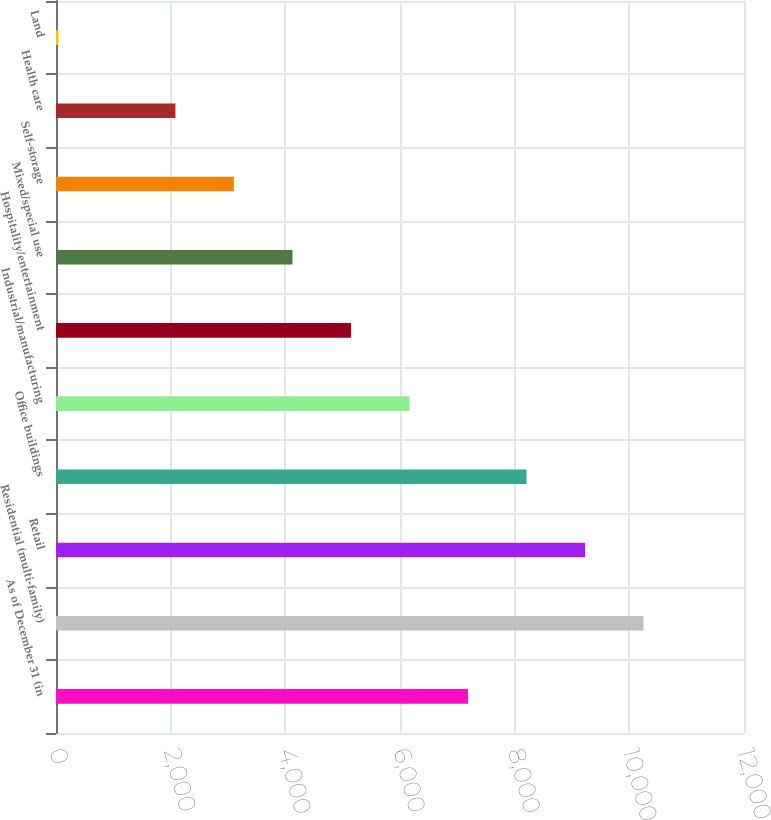<chart> <loc_0><loc_0><loc_500><loc_500><bar_chart><fcel>As of December 31 (in<fcel>Residential (multi-family)<fcel>Retail<fcel>Office buildings<fcel>Industrial/manufacturing<fcel>Hospitality/entertainment<fcel>Mixed/special use<fcel>Self-storage<fcel>Health care<fcel>Land<nl><fcel>7185.65<fcel>10247.3<fcel>9226.75<fcel>8206.2<fcel>6165.1<fcel>5144.55<fcel>4124<fcel>3103.45<fcel>2082.9<fcel>41.8<nl></chart> 